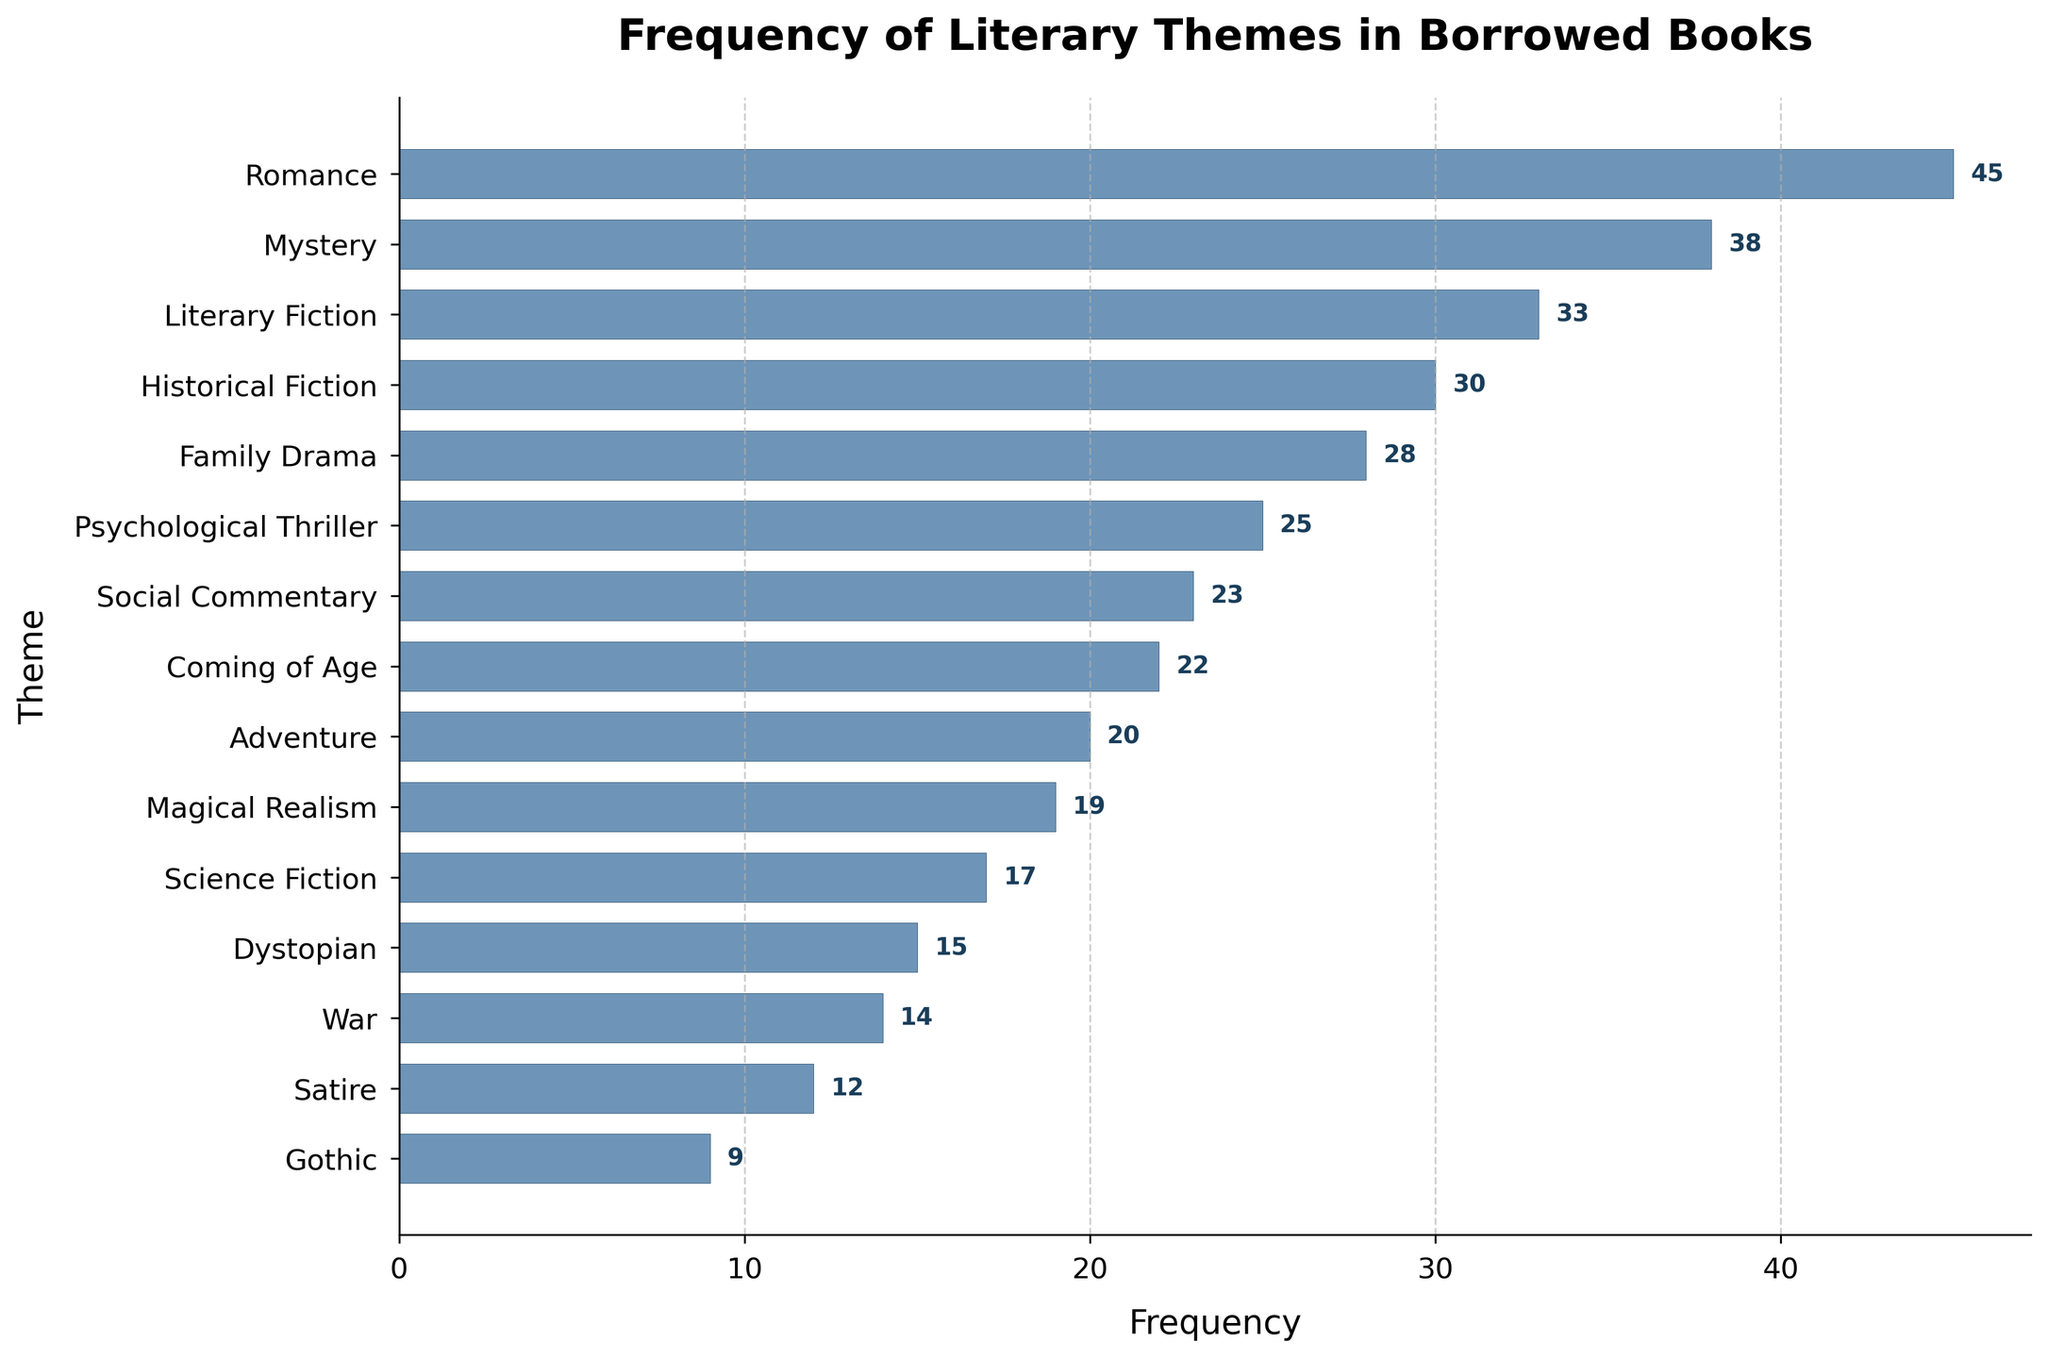what is the title of the chart? The title is usually located at the top of the chart. For this specific plot, it states 'Frequency of Literary Themes in Borrowed Books'.
Answer: Frequency of Literary Themes in Borrowed Books what does the x-axis represent? The x-axis typically represents the measurement unit in this type of plot. Here, it represents the 'Frequency' of the borrowed literary themes.
Answer: Frequency which theme has the highest frequency? By looking at the length of the horizontal bars, the theme with the longest bar has the highest frequency. In this case, 'Romance' has the highest frequency.
Answer: Romance how many themes have a frequency greater than 30? By counting the horizontal bars that extend beyond the value of 30 on the x-axis, we can determine the number of themes. There are four themes: 'Romance', 'Mystery', 'Historical Fiction', and 'Literary Fiction'.
Answer: 4 what is the difference in frequency between the themes with the highest and lowest frequencies? The highest frequency is 'Romance' with 45, and the lowest is 'Gothic' with 9. The difference is calculated as 45 - 9.
Answer: 36 which two themes have the closest frequencies? By looking at themes with very similar bar lengths, we can see that 'Family Drama' and 'Psychological Thriller' have frequencies of 28 and 25, respectively, which are close to each other.
Answer: Family Drama and Psychological Thriller what colors are used for the bars? The color of the bars is visible and distinct in the plot. All the bars are colored with a shade of blue.
Answer: blue what is the average frequency of all themes? To find the average: sum all frequencies and divide by the number of themes. Sum is 45 + 38 + 22 + 30 + 15 + 28 + 19 + 25 + 17 + 33 + 12 + 9 + 20 + 14 + 23 = 350. There are 15 themes, so 350 / 15 = 23.33.
Answer: 23.33 which theme has a higher frequency: 'Science Fiction' or 'Magical Realism'? By comparing the bar lengths and values directly, 'Science Fiction' has a frequency of 17 and 'Magical Realism' has 19. 'Magical Realism' has a higher frequency.
Answer: Magical Realism what is the sum of frequencies for 'Satire', 'War', and 'Adventure'? From the chart inspect the frequencies for these themes and sum them up. 'Satire' (12), 'War' (14), and 'Adventure' (20). Summing them: 12 + 14 + 20 = 46.
Answer: 46 